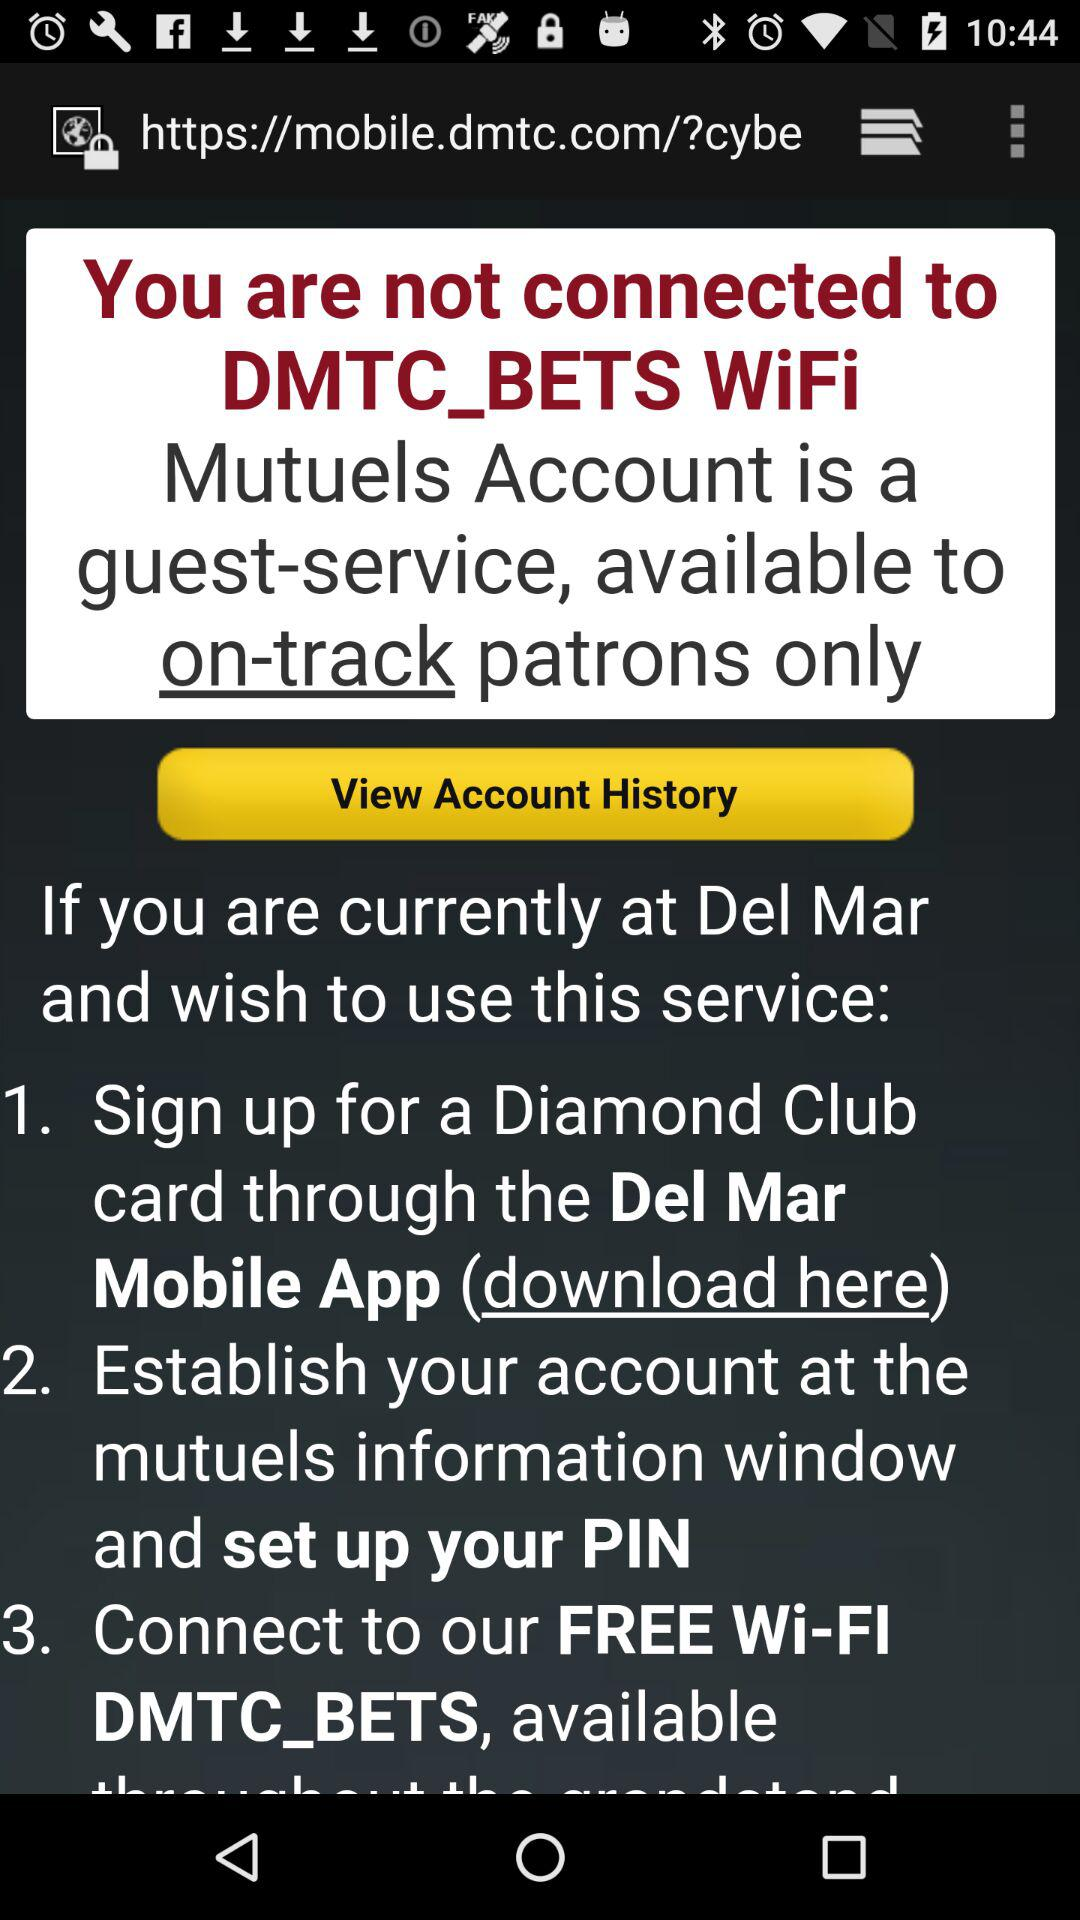How many steps are there to use the Mutuels Account?
Answer the question using a single word or phrase. 3 